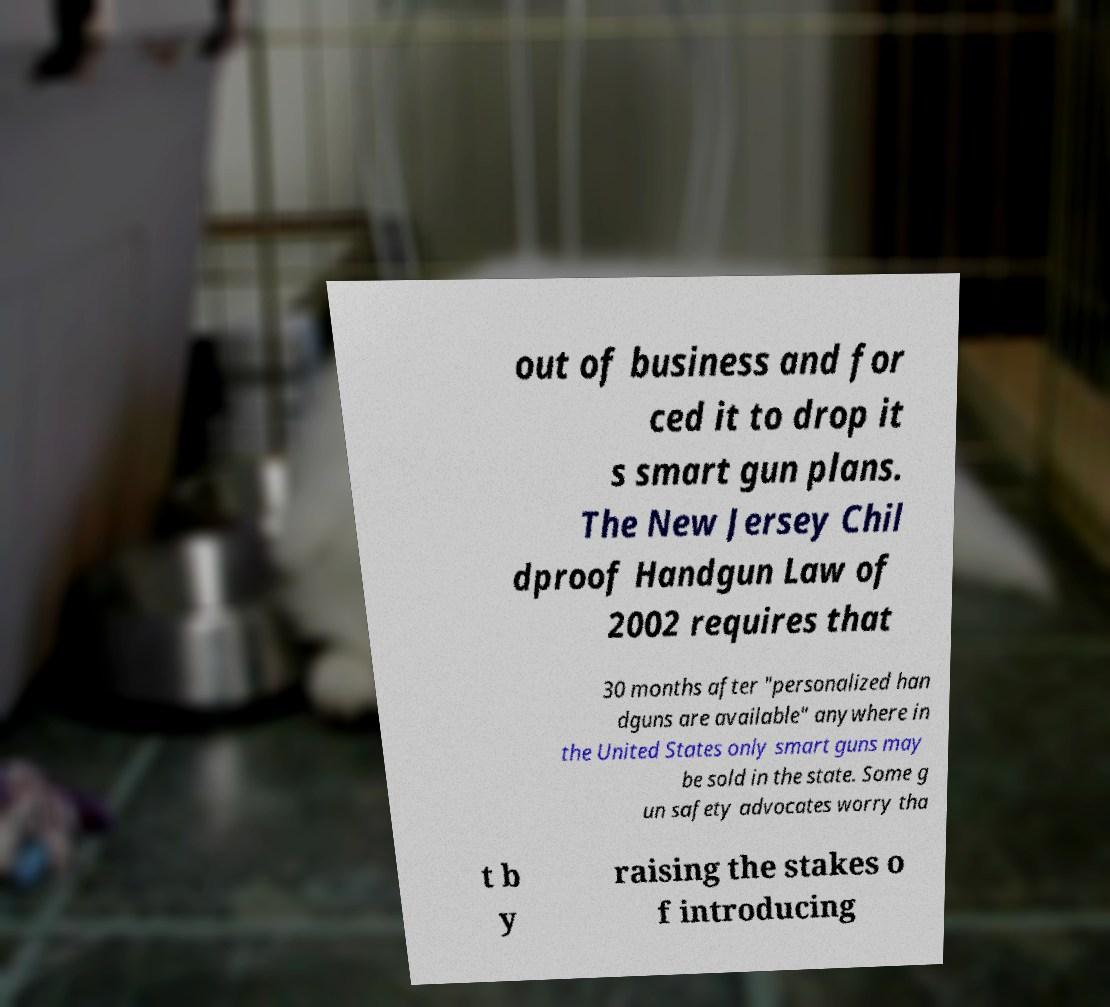Can you accurately transcribe the text from the provided image for me? out of business and for ced it to drop it s smart gun plans. The New Jersey Chil dproof Handgun Law of 2002 requires that 30 months after "personalized han dguns are available" anywhere in the United States only smart guns may be sold in the state. Some g un safety advocates worry tha t b y raising the stakes o f introducing 